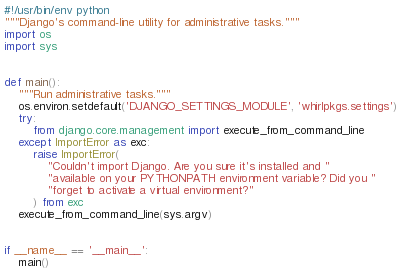Convert code to text. <code><loc_0><loc_0><loc_500><loc_500><_Python_>#!/usr/bin/env python
"""Django's command-line utility for administrative tasks."""
import os
import sys


def main():
    """Run administrative tasks."""
    os.environ.setdefault('DJANGO_SETTINGS_MODULE', 'whirlpkgs.settings')
    try:
        from django.core.management import execute_from_command_line
    except ImportError as exc:
        raise ImportError(
            "Couldn't import Django. Are you sure it's installed and "
            "available on your PYTHONPATH environment variable? Did you "
            "forget to activate a virtual environment?"
        ) from exc
    execute_from_command_line(sys.argv)


if __name__ == '__main__':
    main()
</code> 